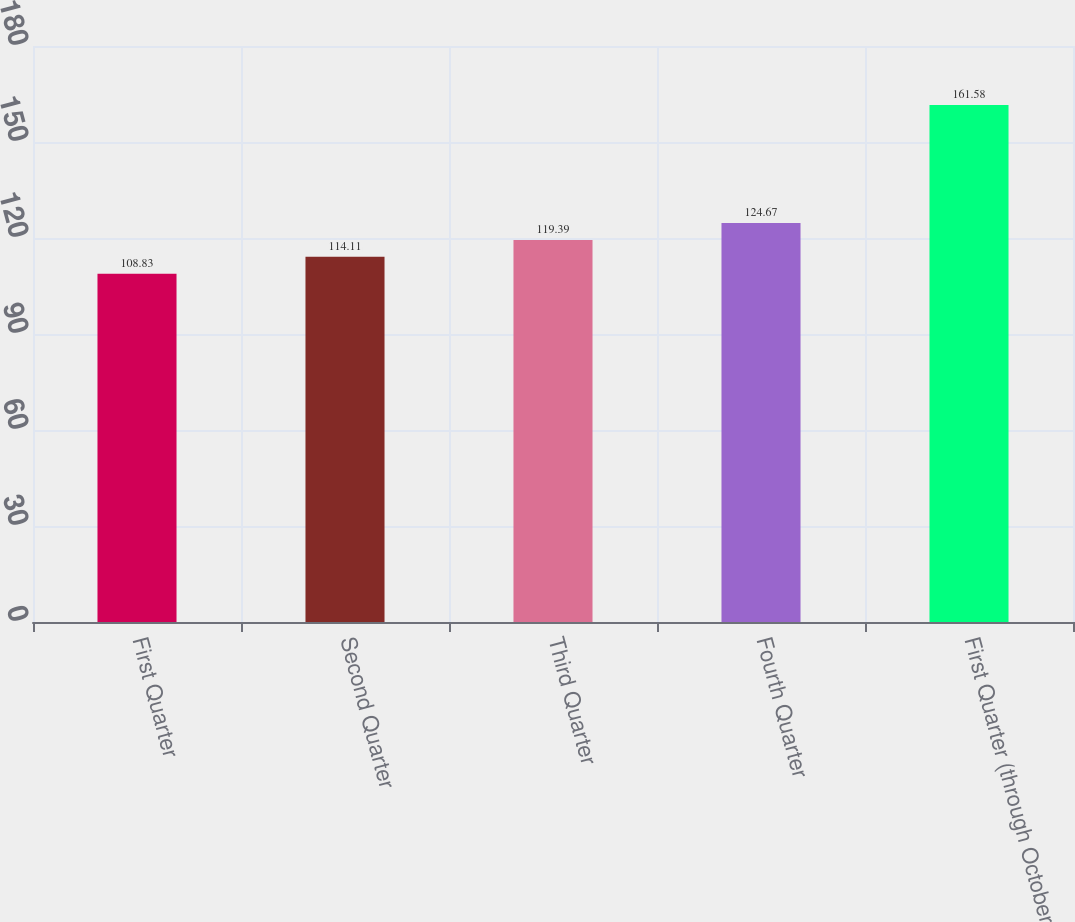Convert chart to OTSL. <chart><loc_0><loc_0><loc_500><loc_500><bar_chart><fcel>First Quarter<fcel>Second Quarter<fcel>Third Quarter<fcel>Fourth Quarter<fcel>First Quarter (through October<nl><fcel>108.83<fcel>114.11<fcel>119.39<fcel>124.67<fcel>161.58<nl></chart> 